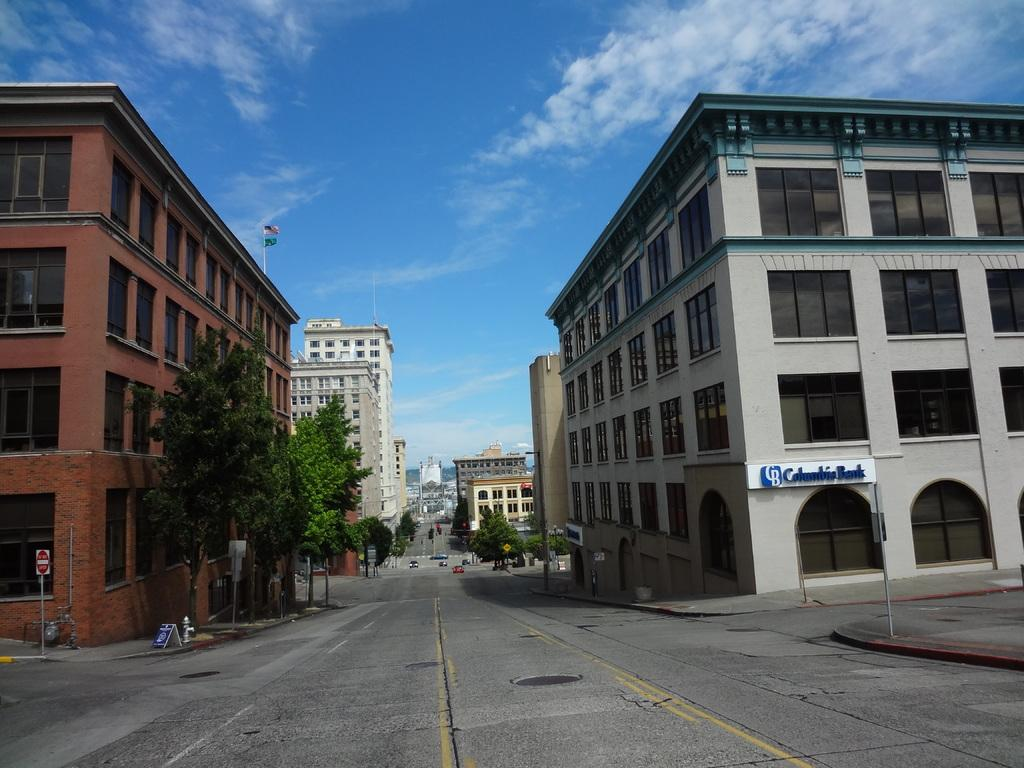What is visible in the center of the image? The sky is visible in the center of the image. What can be seen in the sky? Clouds are present in the image. What type of structures are in the image? There are buildings in the image. What part of the buildings can be seen? Windows are visible in the image. What type of vegetation is present in the image? Trees are present in the image. What are the poles used for in the image? Poles are visible in the image, but their purpose is not specified. What type of signs are present in the image? Sign boards are present in the image. What type of transportation is on the road in the image? Vehicles are on the road in the image. What other objects can be seen in the image? There are other objects in the image, but their specific details are not mentioned. What type of produce can be seen growing in the image? There is no produce visible in the image. 